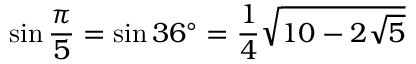Convert formula to latex. <formula><loc_0><loc_0><loc_500><loc_500>\sin { \frac { \pi } { 5 } } = \sin 3 6 ^ { \circ } = { \frac { 1 } { 4 } } { \sqrt { 1 0 - 2 { \sqrt { 5 } } } }</formula> 